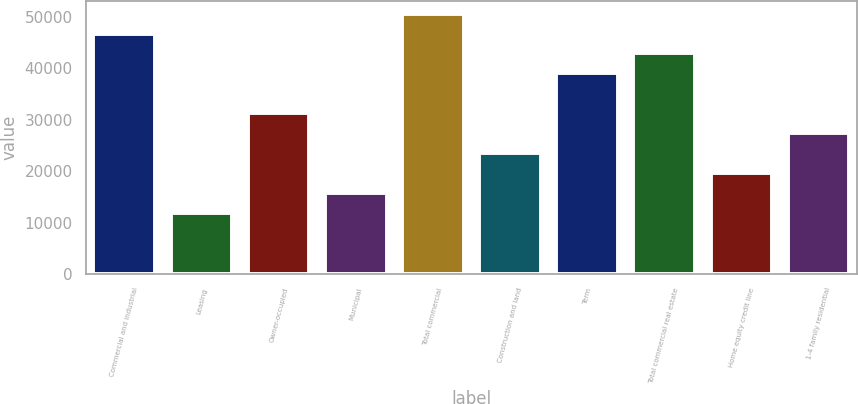Convert chart to OTSL. <chart><loc_0><loc_0><loc_500><loc_500><bar_chart><fcel>Commercial and industrial<fcel>Leasing<fcel>Owner-occupied<fcel>Municipal<fcel>Total commercial<fcel>Construction and land<fcel>Term<fcel>Total commercial real estate<fcel>Home equity credit line<fcel>1-4 family residential<nl><fcel>46810<fcel>11858.5<fcel>31276<fcel>15742<fcel>50693.5<fcel>23509<fcel>39043<fcel>42926.5<fcel>19625.5<fcel>27392.5<nl></chart> 